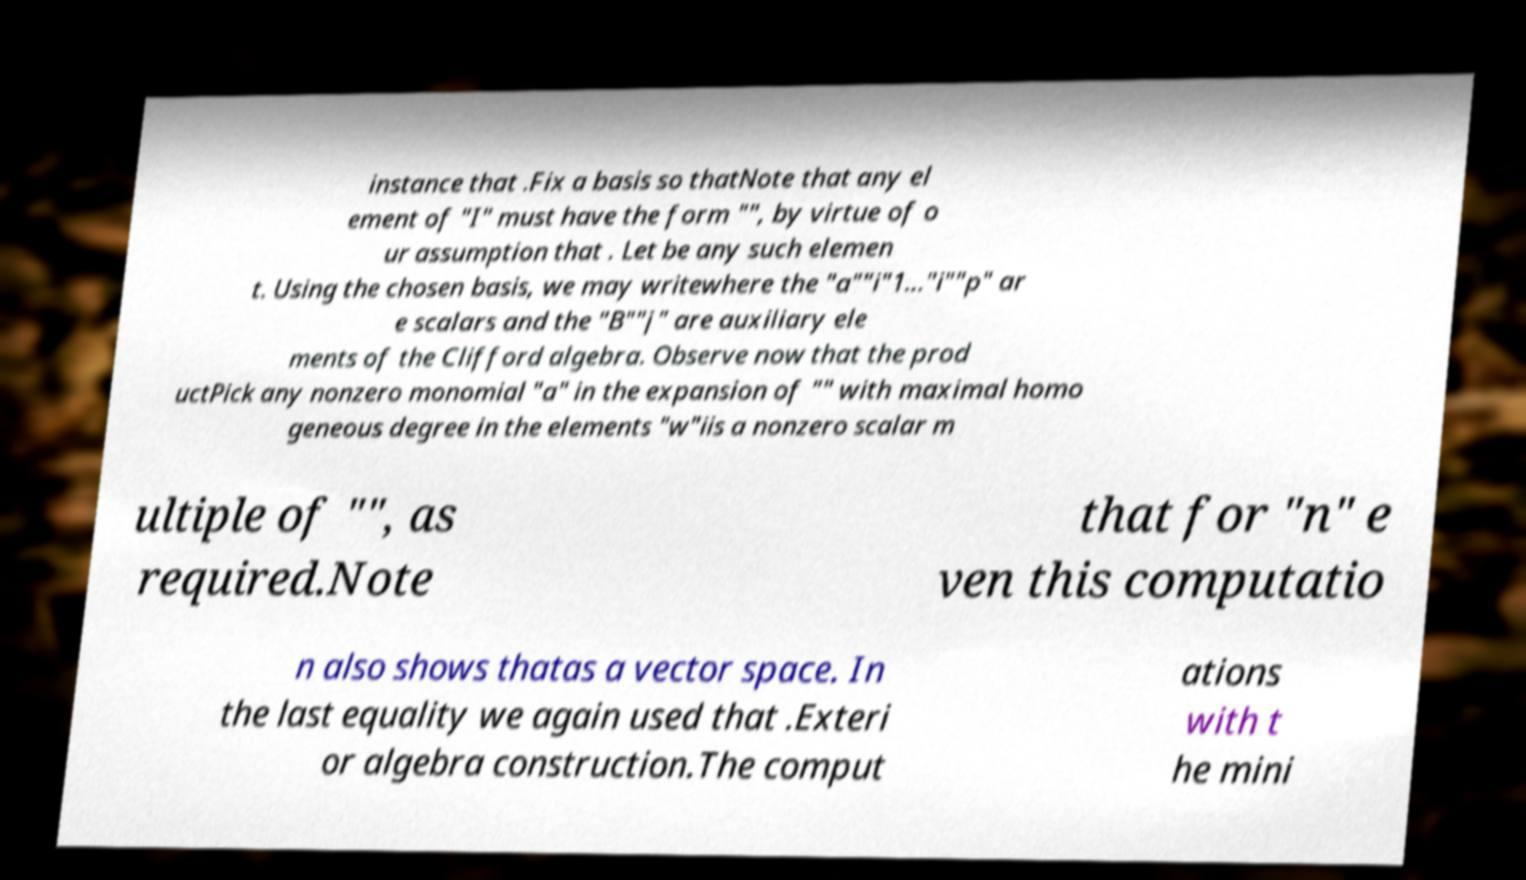Can you read and provide the text displayed in the image?This photo seems to have some interesting text. Can you extract and type it out for me? instance that .Fix a basis so thatNote that any el ement of "I" must have the form "", by virtue of o ur assumption that . Let be any such elemen t. Using the chosen basis, we may writewhere the "a""i"1..."i""p" ar e scalars and the "B""j" are auxiliary ele ments of the Clifford algebra. Observe now that the prod uctPick any nonzero monomial "a" in the expansion of "" with maximal homo geneous degree in the elements "w"iis a nonzero scalar m ultiple of "", as required.Note that for "n" e ven this computatio n also shows thatas a vector space. In the last equality we again used that .Exteri or algebra construction.The comput ations with t he mini 